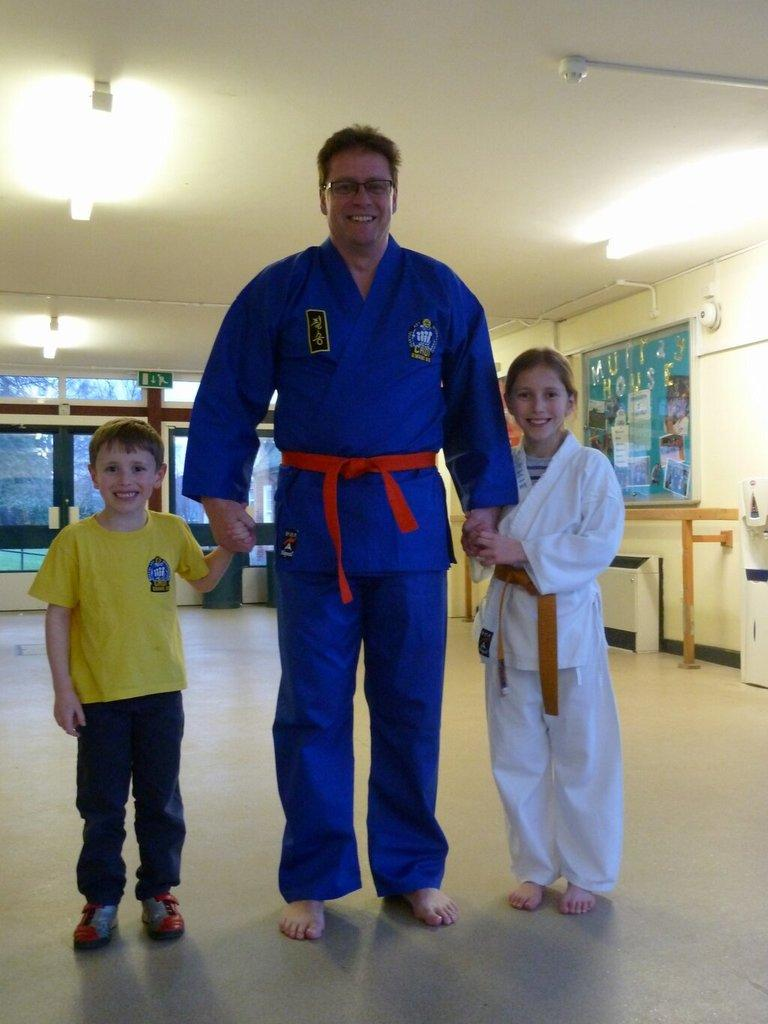Who is present in the image? There is a man and two kids in the image. What are the man and kids doing in the image? The man and kids are standing on the floor. What can be seen in the background of the image? There are walls and windows visible in the background of the image. What is at the top of the image? There are lights at the top of the image. What type of country is depicted in the image? There is no country depicted in the image; it features a man and two kids standing on the floor with a background of walls and windows. Can you tell me how many worms are crawling on the man's arm in the image? There are no worms present in the image. 